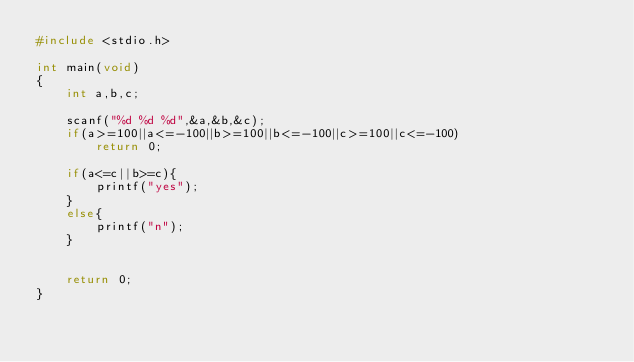<code> <loc_0><loc_0><loc_500><loc_500><_C_>#include <stdio.h>

int main(void)
{
	int a,b,c;
	
	scanf("%d %d %d",&a,&b,&c);
	if(a>=100||a<=-100||b>=100||b<=-100||c>=100||c<=-100)
		return 0;
	
	if(a<=c||b>=c){
		printf("yes");
	}
	else{
		printf("n");
	}
	
	
	return 0;
}

</code> 